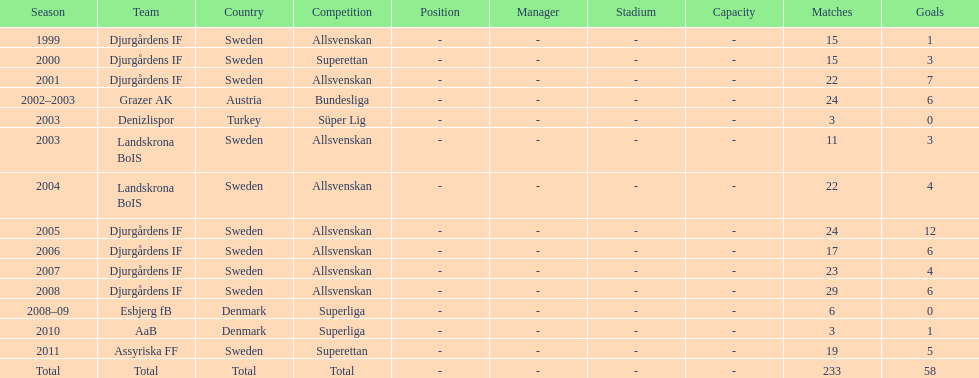What was the number of goals he scored in 2005? 12. 